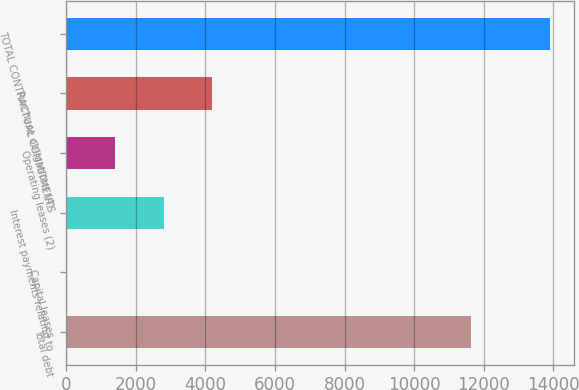<chart> <loc_0><loc_0><loc_500><loc_500><bar_chart><fcel>Total debt<fcel>Capital leases<fcel>Interest payments relating to<fcel>Operating leases (2)<fcel>Purchase obligations (4)<fcel>TOTAL CONTRACTUAL COMMITMENTS<nl><fcel>11635<fcel>16<fcel>2795.8<fcel>1405.9<fcel>4185.7<fcel>13915<nl></chart> 